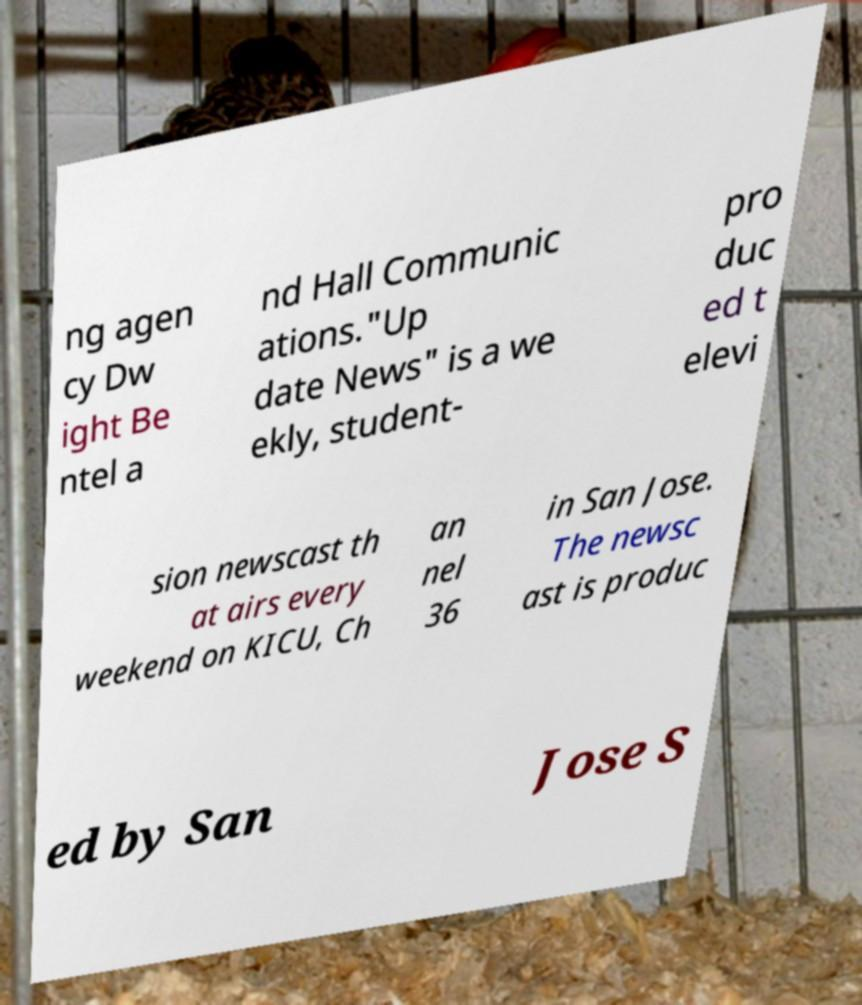Please identify and transcribe the text found in this image. ng agen cy Dw ight Be ntel a nd Hall Communic ations."Up date News" is a we ekly, student- pro duc ed t elevi sion newscast th at airs every weekend on KICU, Ch an nel 36 in San Jose. The newsc ast is produc ed by San Jose S 